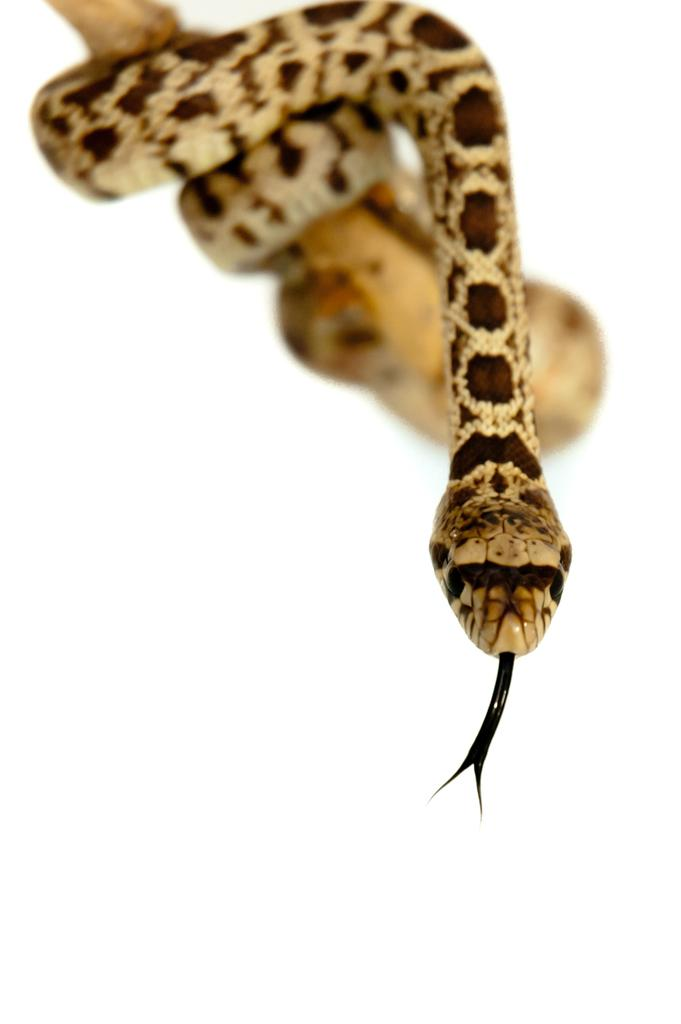What animal is the main subject of the image? There is a snake in the image. How is the snake being displayed or held? The snake is on a stick. What is the color of the snake? The snake is white in color. Are there any additional markings or patterns on the snake? Yes, there are brown color marks on the snake. What is the color of the background in the image? The background of the image is white. What type of note is the snake holding in the image? There is no note present in the image; the snake is on a stick. What is the snake doing with the tin in the image? There is no tin present in the image; the snake is on a stick. 